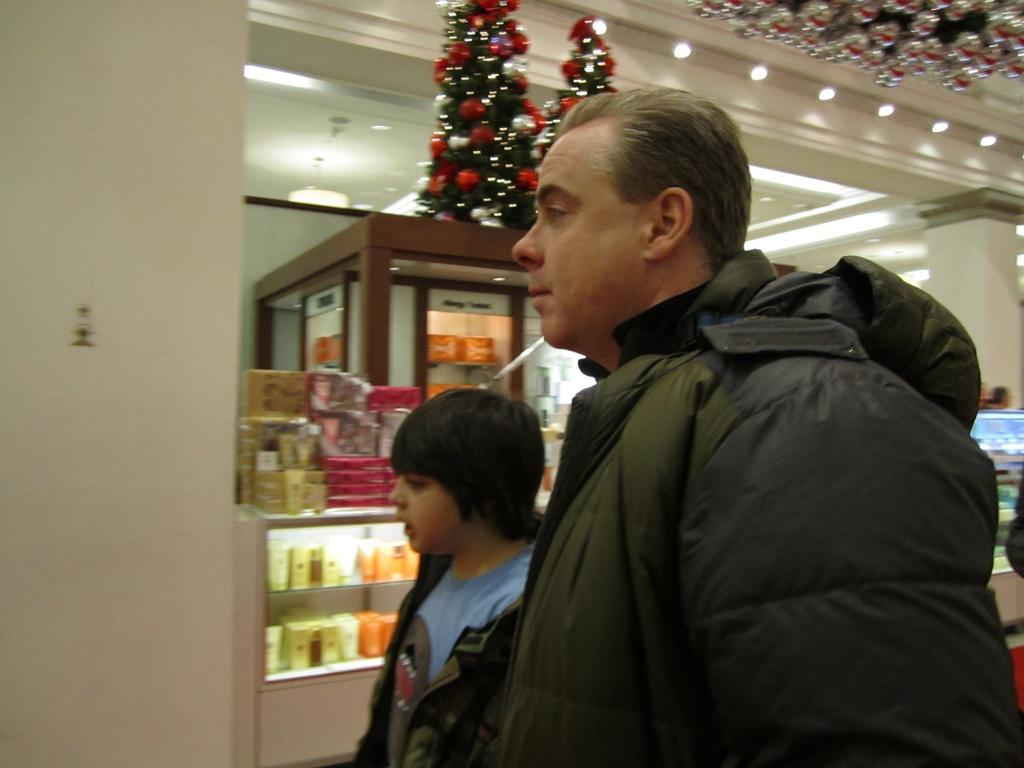How many people are present in the image? There are two persons standing in the image. What can be seen behind the people in the image? There is a wall in the image. What type of objects are in the background of the image? There are objects in glass racks in the background of the image. What is illuminating the scene in the image? There are lights visible in the image. What season might the image be depicting? There are Christmas trees in the image, suggesting that it might be depicting the Christmas season. What type of test is being conducted in the image? There is no indication of a test being conducted in the image; it features two people standing near a wall with glass racks and Christmas trees in the background. What type of basin is visible in the image? There is no basin present in the image. 